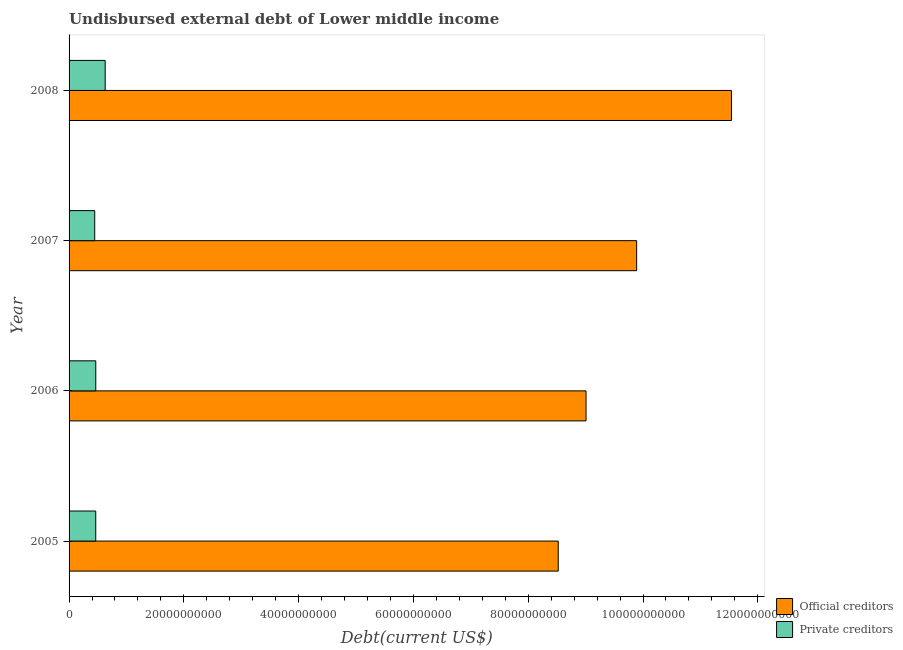How many different coloured bars are there?
Give a very brief answer. 2. How many groups of bars are there?
Offer a very short reply. 4. What is the label of the 1st group of bars from the top?
Offer a terse response. 2008. What is the undisbursed external debt of official creditors in 2007?
Make the answer very short. 9.89e+1. Across all years, what is the maximum undisbursed external debt of official creditors?
Offer a terse response. 1.15e+11. Across all years, what is the minimum undisbursed external debt of private creditors?
Your answer should be very brief. 4.47e+09. In which year was the undisbursed external debt of official creditors minimum?
Provide a short and direct response. 2005. What is the total undisbursed external debt of private creditors in the graph?
Your answer should be compact. 2.01e+1. What is the difference between the undisbursed external debt of private creditors in 2006 and that in 2008?
Offer a terse response. -1.64e+09. What is the difference between the undisbursed external debt of official creditors in 2005 and the undisbursed external debt of private creditors in 2008?
Keep it short and to the point. 7.89e+1. What is the average undisbursed external debt of private creditors per year?
Your response must be concise. 5.02e+09. In the year 2007, what is the difference between the undisbursed external debt of official creditors and undisbursed external debt of private creditors?
Ensure brevity in your answer.  9.44e+1. In how many years, is the undisbursed external debt of private creditors greater than 80000000000 US$?
Provide a short and direct response. 0. What is the ratio of the undisbursed external debt of official creditors in 2006 to that in 2008?
Keep it short and to the point. 0.78. Is the undisbursed external debt of official creditors in 2007 less than that in 2008?
Your answer should be very brief. Yes. What is the difference between the highest and the second highest undisbursed external debt of private creditors?
Keep it short and to the point. 1.64e+09. What is the difference between the highest and the lowest undisbursed external debt of official creditors?
Provide a short and direct response. 3.02e+1. What does the 1st bar from the top in 2007 represents?
Keep it short and to the point. Private creditors. What does the 1st bar from the bottom in 2007 represents?
Offer a very short reply. Official creditors. Does the graph contain any zero values?
Keep it short and to the point. No. How many legend labels are there?
Ensure brevity in your answer.  2. How are the legend labels stacked?
Offer a very short reply. Vertical. What is the title of the graph?
Keep it short and to the point. Undisbursed external debt of Lower middle income. Does "Boys" appear as one of the legend labels in the graph?
Your answer should be very brief. No. What is the label or title of the X-axis?
Give a very brief answer. Debt(current US$). What is the Debt(current US$) of Official creditors in 2005?
Give a very brief answer. 8.52e+1. What is the Debt(current US$) in Private creditors in 2005?
Provide a short and direct response. 4.65e+09. What is the Debt(current US$) of Official creditors in 2006?
Offer a terse response. 9.01e+1. What is the Debt(current US$) of Private creditors in 2006?
Offer a very short reply. 4.65e+09. What is the Debt(current US$) of Official creditors in 2007?
Ensure brevity in your answer.  9.89e+1. What is the Debt(current US$) of Private creditors in 2007?
Make the answer very short. 4.47e+09. What is the Debt(current US$) of Official creditors in 2008?
Your answer should be very brief. 1.15e+11. What is the Debt(current US$) of Private creditors in 2008?
Offer a terse response. 6.29e+09. Across all years, what is the maximum Debt(current US$) in Official creditors?
Offer a very short reply. 1.15e+11. Across all years, what is the maximum Debt(current US$) of Private creditors?
Provide a succinct answer. 6.29e+09. Across all years, what is the minimum Debt(current US$) of Official creditors?
Your response must be concise. 8.52e+1. Across all years, what is the minimum Debt(current US$) of Private creditors?
Offer a very short reply. 4.47e+09. What is the total Debt(current US$) of Official creditors in the graph?
Your response must be concise. 3.90e+11. What is the total Debt(current US$) of Private creditors in the graph?
Make the answer very short. 2.01e+1. What is the difference between the Debt(current US$) in Official creditors in 2005 and that in 2006?
Give a very brief answer. -4.85e+09. What is the difference between the Debt(current US$) of Private creditors in 2005 and that in 2006?
Ensure brevity in your answer.  -6.09e+06. What is the difference between the Debt(current US$) of Official creditors in 2005 and that in 2007?
Offer a terse response. -1.37e+1. What is the difference between the Debt(current US$) of Private creditors in 2005 and that in 2007?
Ensure brevity in your answer.  1.81e+08. What is the difference between the Debt(current US$) of Official creditors in 2005 and that in 2008?
Provide a short and direct response. -3.02e+1. What is the difference between the Debt(current US$) of Private creditors in 2005 and that in 2008?
Your response must be concise. -1.65e+09. What is the difference between the Debt(current US$) in Official creditors in 2006 and that in 2007?
Offer a very short reply. -8.82e+09. What is the difference between the Debt(current US$) of Private creditors in 2006 and that in 2007?
Keep it short and to the point. 1.87e+08. What is the difference between the Debt(current US$) of Official creditors in 2006 and that in 2008?
Keep it short and to the point. -2.53e+1. What is the difference between the Debt(current US$) of Private creditors in 2006 and that in 2008?
Provide a succinct answer. -1.64e+09. What is the difference between the Debt(current US$) in Official creditors in 2007 and that in 2008?
Make the answer very short. -1.65e+1. What is the difference between the Debt(current US$) in Private creditors in 2007 and that in 2008?
Offer a very short reply. -1.83e+09. What is the difference between the Debt(current US$) of Official creditors in 2005 and the Debt(current US$) of Private creditors in 2006?
Your response must be concise. 8.06e+1. What is the difference between the Debt(current US$) in Official creditors in 2005 and the Debt(current US$) in Private creditors in 2007?
Provide a short and direct response. 8.08e+1. What is the difference between the Debt(current US$) in Official creditors in 2005 and the Debt(current US$) in Private creditors in 2008?
Offer a very short reply. 7.89e+1. What is the difference between the Debt(current US$) of Official creditors in 2006 and the Debt(current US$) of Private creditors in 2007?
Provide a short and direct response. 8.56e+1. What is the difference between the Debt(current US$) in Official creditors in 2006 and the Debt(current US$) in Private creditors in 2008?
Your response must be concise. 8.38e+1. What is the difference between the Debt(current US$) in Official creditors in 2007 and the Debt(current US$) in Private creditors in 2008?
Your response must be concise. 9.26e+1. What is the average Debt(current US$) of Official creditors per year?
Ensure brevity in your answer.  9.74e+1. What is the average Debt(current US$) of Private creditors per year?
Your answer should be very brief. 5.02e+09. In the year 2005, what is the difference between the Debt(current US$) in Official creditors and Debt(current US$) in Private creditors?
Your answer should be very brief. 8.06e+1. In the year 2006, what is the difference between the Debt(current US$) of Official creditors and Debt(current US$) of Private creditors?
Make the answer very short. 8.54e+1. In the year 2007, what is the difference between the Debt(current US$) in Official creditors and Debt(current US$) in Private creditors?
Make the answer very short. 9.44e+1. In the year 2008, what is the difference between the Debt(current US$) in Official creditors and Debt(current US$) in Private creditors?
Make the answer very short. 1.09e+11. What is the ratio of the Debt(current US$) of Official creditors in 2005 to that in 2006?
Offer a terse response. 0.95. What is the ratio of the Debt(current US$) in Private creditors in 2005 to that in 2006?
Offer a very short reply. 1. What is the ratio of the Debt(current US$) of Official creditors in 2005 to that in 2007?
Your answer should be compact. 0.86. What is the ratio of the Debt(current US$) of Private creditors in 2005 to that in 2007?
Provide a succinct answer. 1.04. What is the ratio of the Debt(current US$) in Official creditors in 2005 to that in 2008?
Make the answer very short. 0.74. What is the ratio of the Debt(current US$) of Private creditors in 2005 to that in 2008?
Give a very brief answer. 0.74. What is the ratio of the Debt(current US$) of Official creditors in 2006 to that in 2007?
Make the answer very short. 0.91. What is the ratio of the Debt(current US$) in Private creditors in 2006 to that in 2007?
Your answer should be very brief. 1.04. What is the ratio of the Debt(current US$) in Official creditors in 2006 to that in 2008?
Provide a succinct answer. 0.78. What is the ratio of the Debt(current US$) of Private creditors in 2006 to that in 2008?
Offer a very short reply. 0.74. What is the ratio of the Debt(current US$) in Official creditors in 2007 to that in 2008?
Provide a succinct answer. 0.86. What is the ratio of the Debt(current US$) in Private creditors in 2007 to that in 2008?
Your answer should be very brief. 0.71. What is the difference between the highest and the second highest Debt(current US$) in Official creditors?
Ensure brevity in your answer.  1.65e+1. What is the difference between the highest and the second highest Debt(current US$) in Private creditors?
Provide a succinct answer. 1.64e+09. What is the difference between the highest and the lowest Debt(current US$) of Official creditors?
Offer a very short reply. 3.02e+1. What is the difference between the highest and the lowest Debt(current US$) in Private creditors?
Provide a short and direct response. 1.83e+09. 